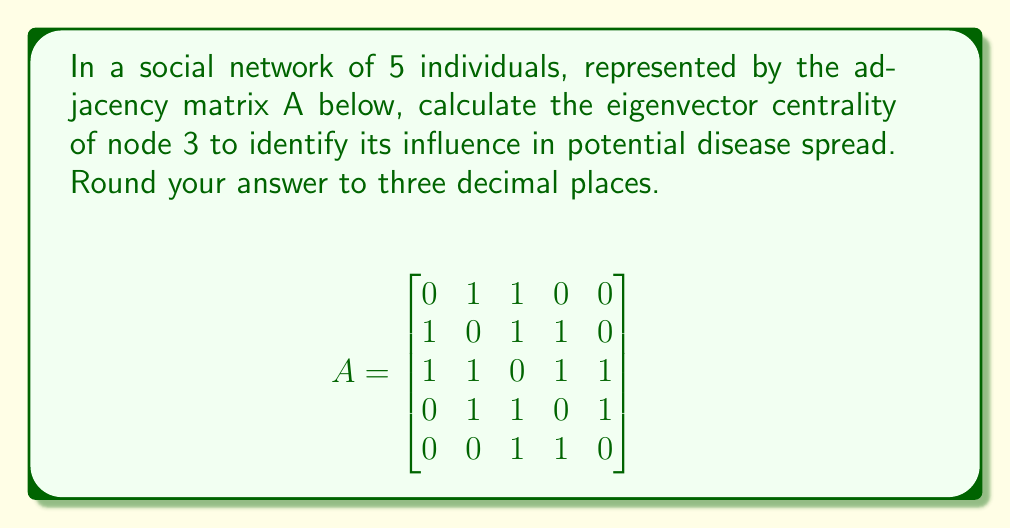Provide a solution to this math problem. To calculate the eigenvector centrality:

1. Find the largest eigenvalue ($\lambda_{max}$) and its corresponding eigenvector:
   $$det(A - \lambda I) = 0$$
   Solving this, we get $\lambda_{max} \approx 2.4815$

2. Find the corresponding eigenvector $\vec{v}$:
   $$(A - \lambda_{max}I)\vec{v} = \vec{0}$$
   Solving this system, we get:
   $$\vec{v} \approx [0.3768, 0.5209, 0.6015, 0.4209, 0.2406]^T$$

3. Normalize the eigenvector:
   $$\vec{v}_{norm} = \frac{\vec{v}}{\|\vec{v}\|} \approx [0.3991, 0.5519, 0.6373, 0.4459, 0.2549]^T$$

4. The eigenvector centrality of node 3 is the third component of $\vec{v}_{norm}$:
   $$0.6373$$

5. Rounding to three decimal places:
   $$0.637$$
Answer: 0.637 